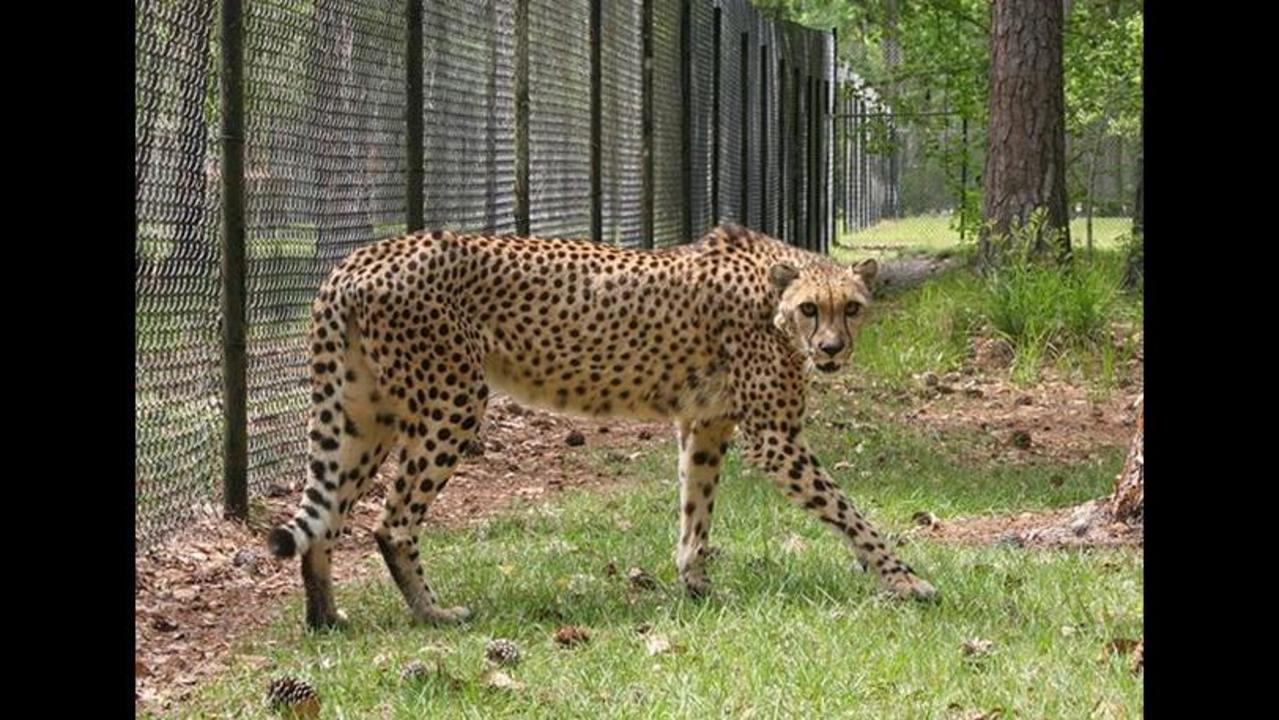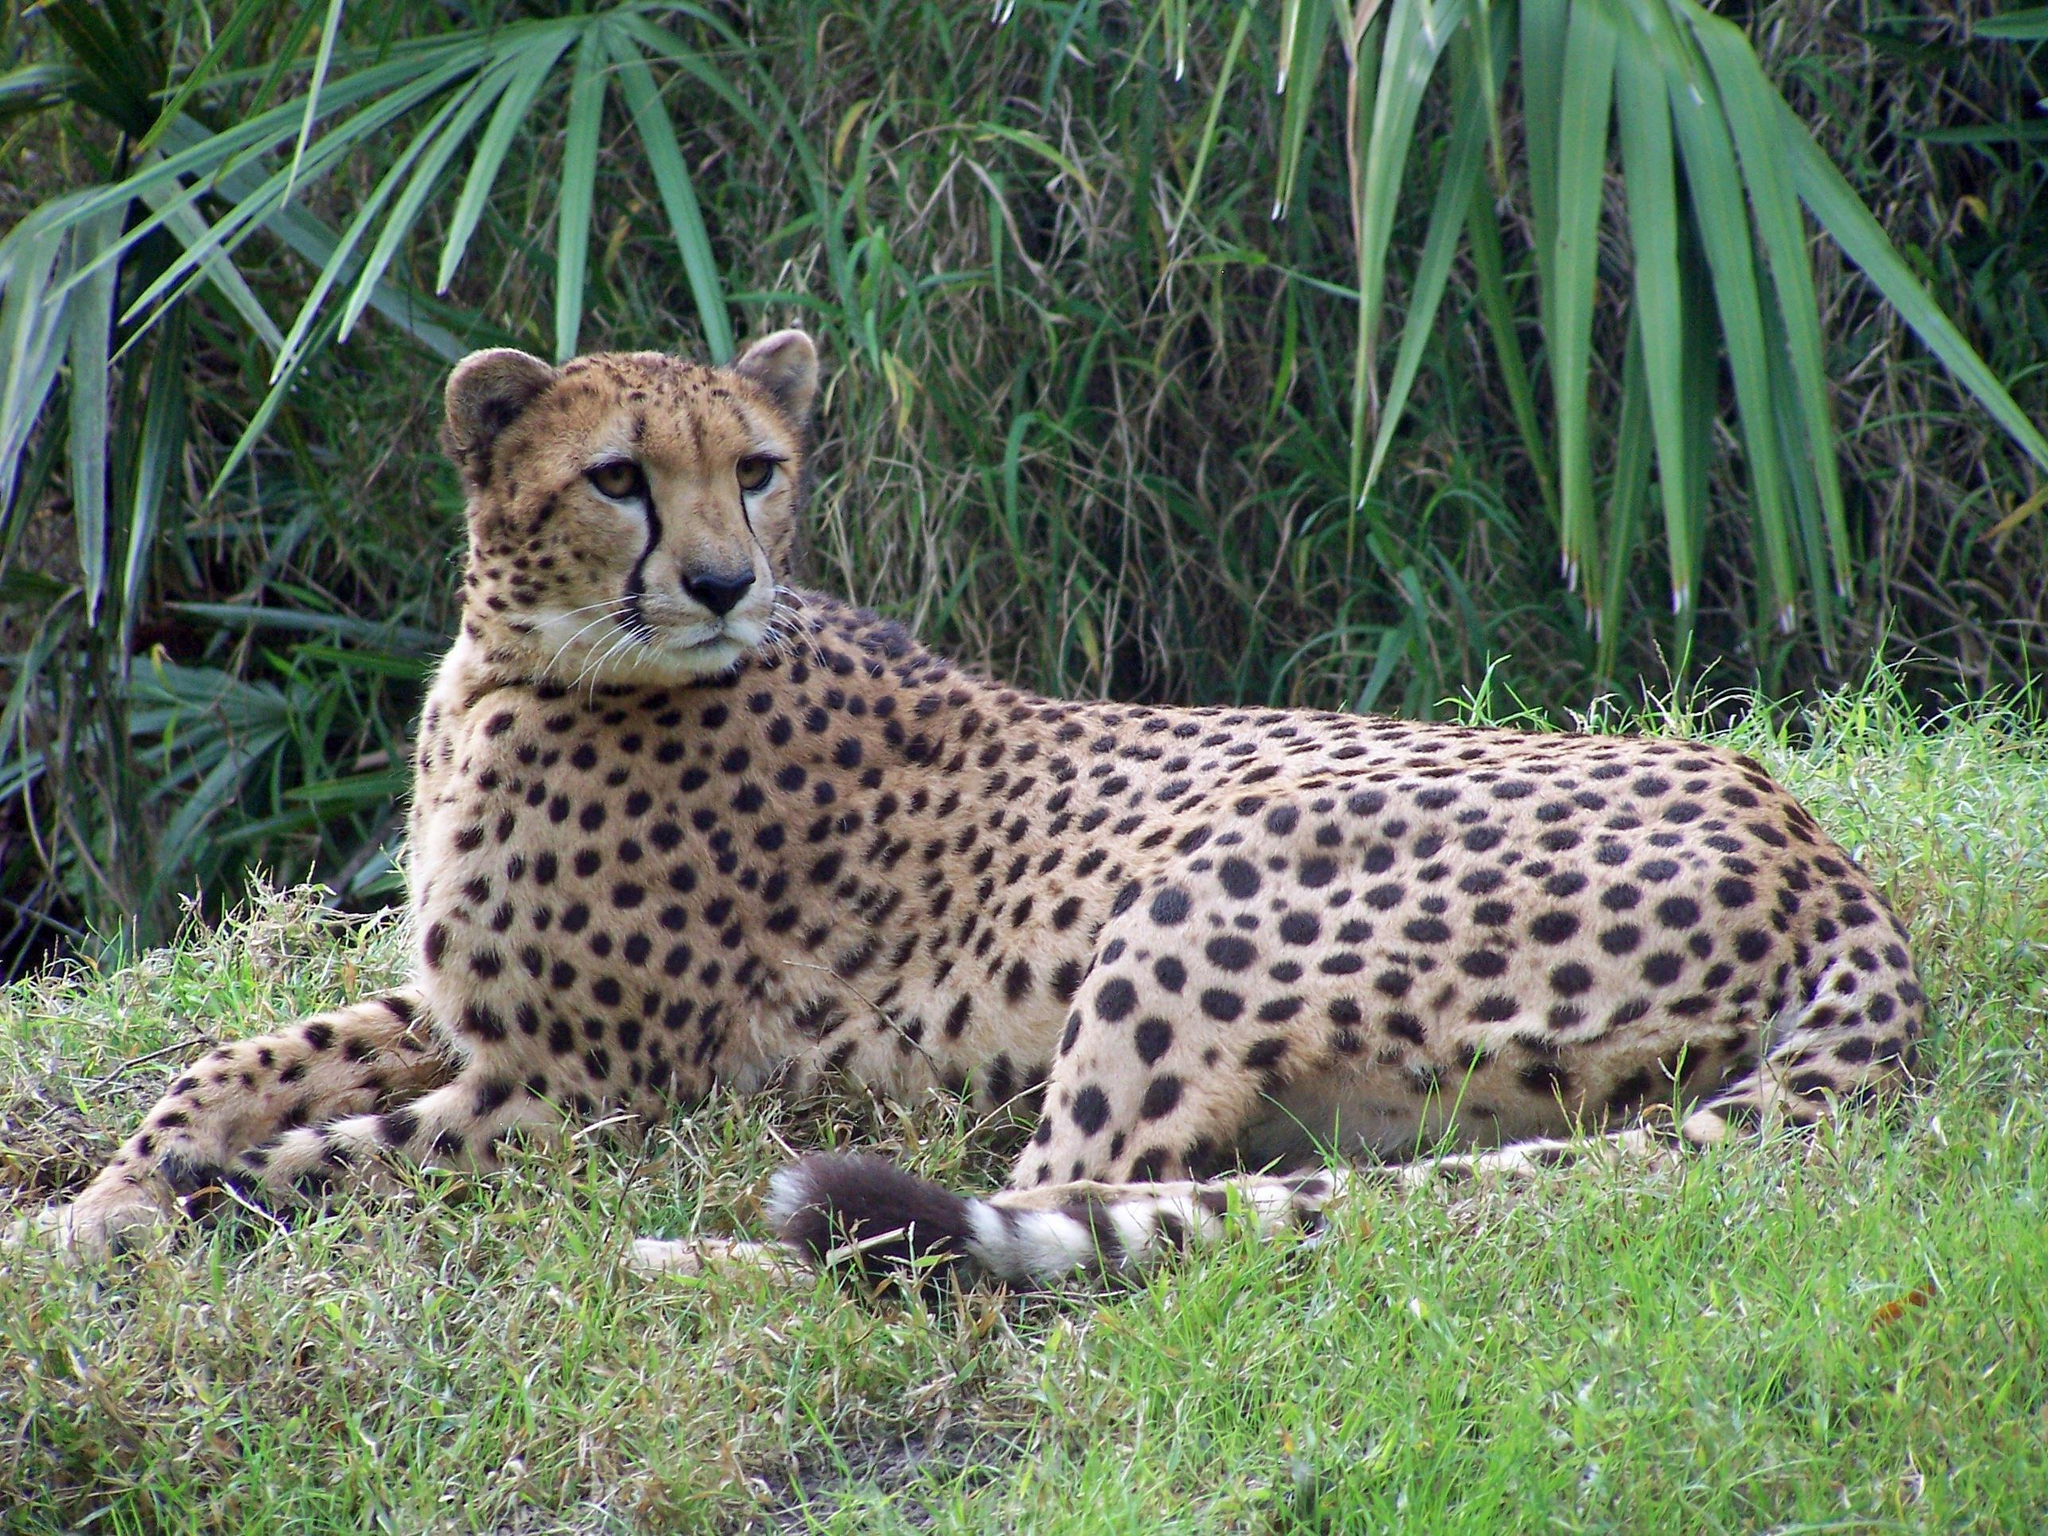The first image is the image on the left, the second image is the image on the right. Considering the images on both sides, is "There are two leopards in one of the images." valid? Answer yes or no. No. The first image is the image on the left, the second image is the image on the right. Analyze the images presented: Is the assertion "There are 3 cheetahs." valid? Answer yes or no. No. 